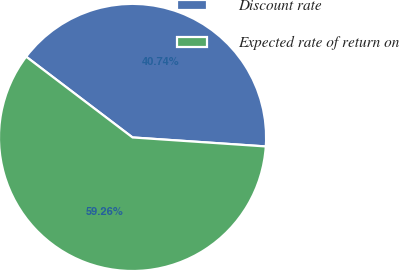<chart> <loc_0><loc_0><loc_500><loc_500><pie_chart><fcel>Discount rate<fcel>Expected rate of return on<nl><fcel>40.74%<fcel>59.26%<nl></chart> 